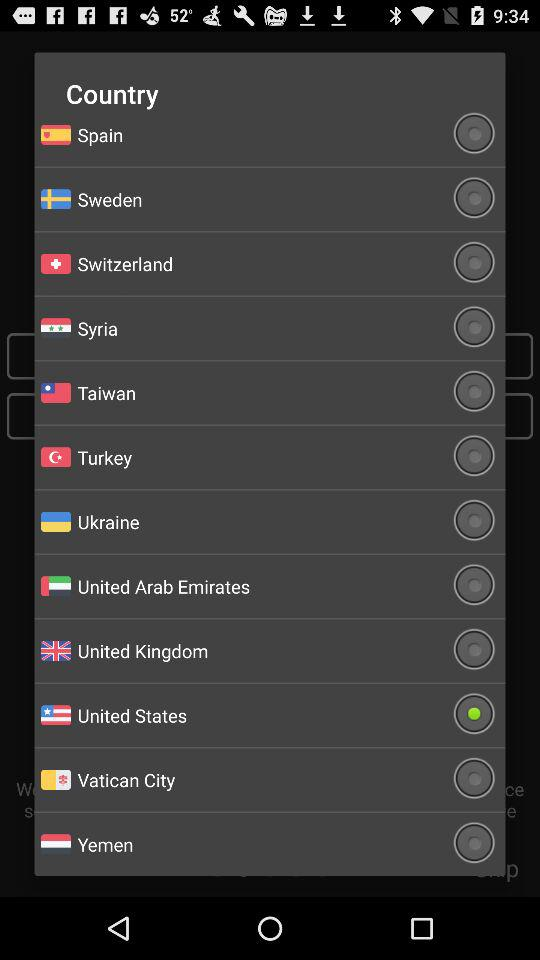Which radio button is selected? The selected radio button is "United States". 